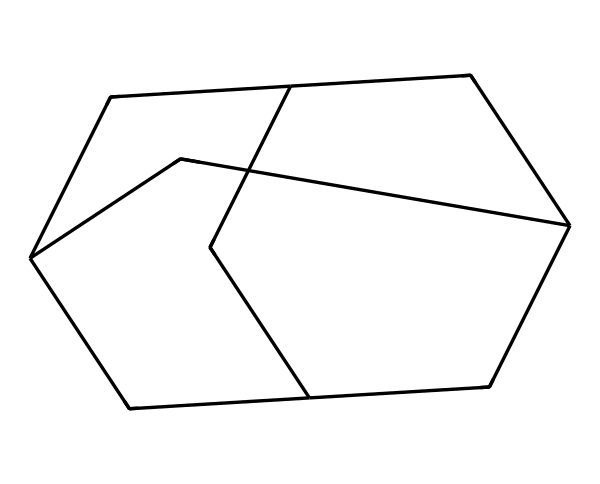What is the molecular formula of adamantane? To find the molecular formula, we identify the carbon and hydrogen atoms in the structure. The structure contains 10 carbon atoms and 16 hydrogen atoms, giving us the molecular formula C10H16.
Answer: C10H16 How many carbon atoms are in the structure? By directly visualizing the chemical structure, we can count the number of carbon atoms, which appears to be 10.
Answer: 10 What type of compound is adamantane classified as? Adamantane is classified as a cage hydrocarbon because it consists of a polycyclic structure that resembles a cage.
Answer: cage hydrocarbon Does adamantane contain any double bonds? Observing the SMILES representation and chemical structure, we see that there are no double bonds present, as all carbons are saturated with single bonds.
Answer: no What is the hybridization of the carbon atoms in adamantane? The carbon atoms in the structure are mostly tetrahedral, which indicates they are sp3 hybridized. Each carbon forms four single bonds, characteristic of sp3 hybridization.
Answer: sp3 How many hydrogen atoms are typically associated with each carbon in adamantane? In adamantane, each carbon atom bonds with hydrogen atoms in a manner that typically satisfies the tetravalence of carbon, leading to an average of 1.6 hydrogen atoms per carbon due to the overall structure.
Answer: 1.6 What is the primary application of adamantane in pharmaceuticals? Adamantane is primarily used in the formulation of antiviral drugs, notably for treating influenza. Its unique structure affords it the ability to interact with viral proteins effectively.
Answer: antiviral drugs 